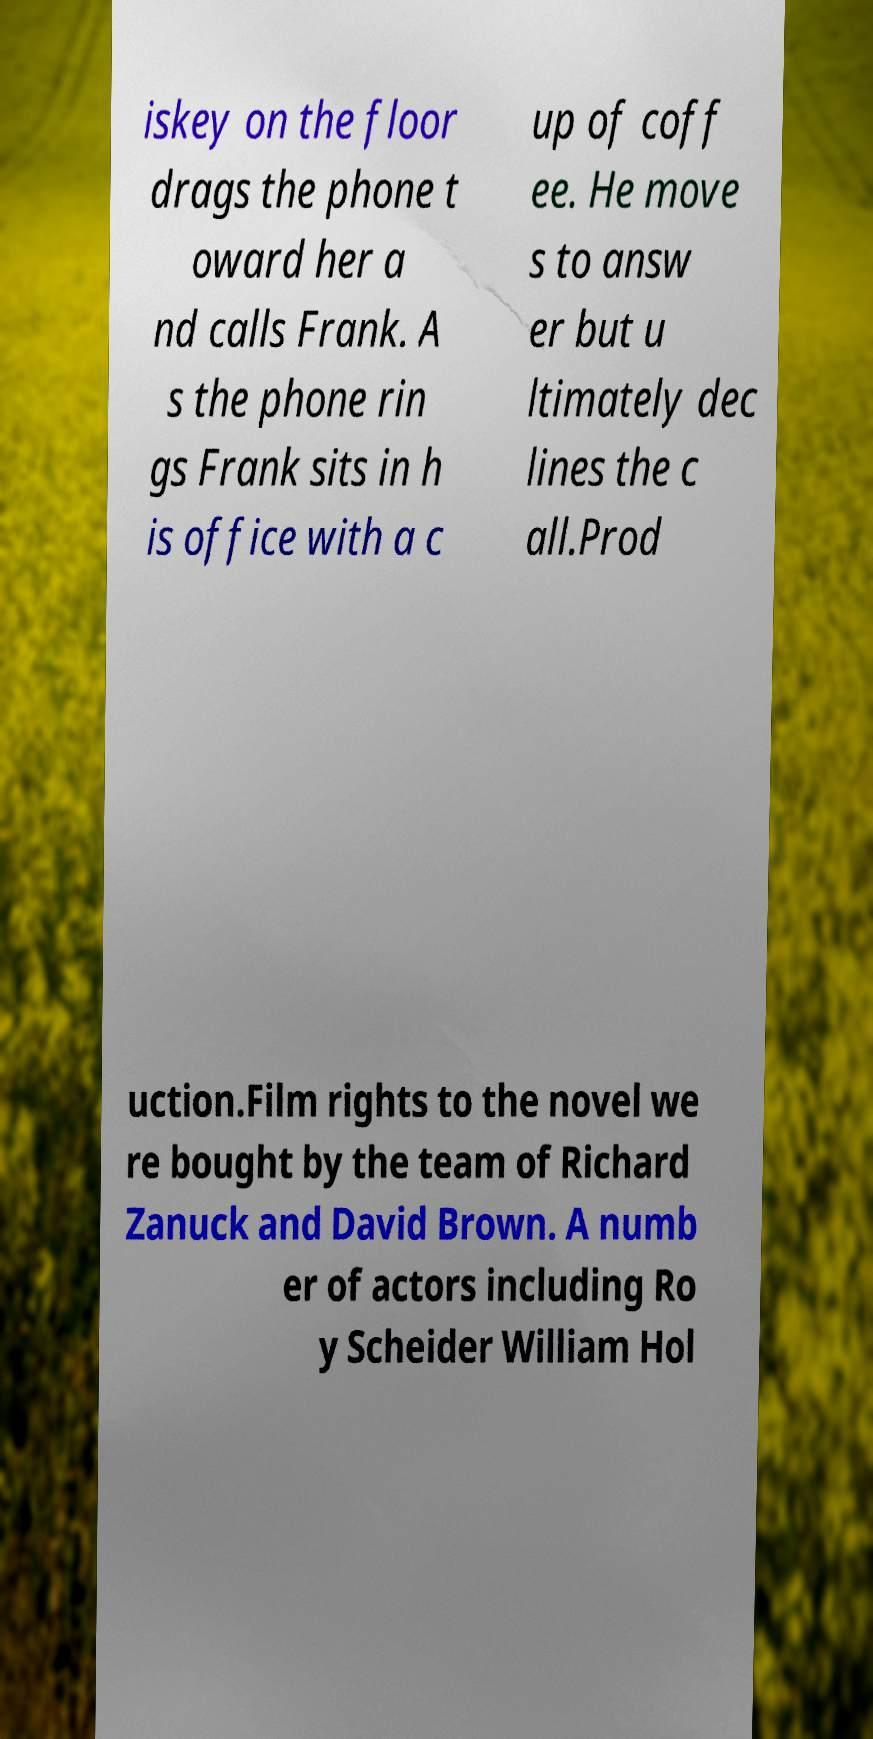Can you accurately transcribe the text from the provided image for me? iskey on the floor drags the phone t oward her a nd calls Frank. A s the phone rin gs Frank sits in h is office with a c up of coff ee. He move s to answ er but u ltimately dec lines the c all.Prod uction.Film rights to the novel we re bought by the team of Richard Zanuck and David Brown. A numb er of actors including Ro y Scheider William Hol 